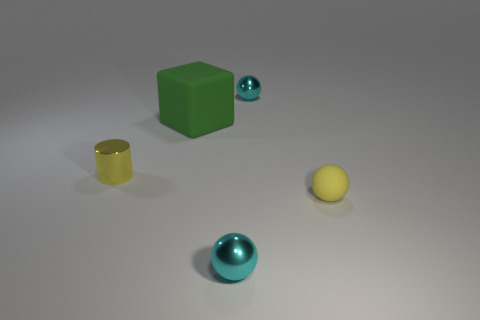Subtract all tiny yellow spheres. How many spheres are left? 2 Add 1 small cyan metallic things. How many objects exist? 6 Subtract all gray cylinders. How many cyan balls are left? 2 Subtract 2 balls. How many balls are left? 1 Subtract all blocks. How many objects are left? 4 Subtract 2 cyan balls. How many objects are left? 3 Subtract all blue spheres. Subtract all brown cylinders. How many spheres are left? 3 Subtract all small yellow rubber objects. Subtract all big blocks. How many objects are left? 3 Add 1 small metallic things. How many small metallic things are left? 4 Add 2 yellow metal objects. How many yellow metal objects exist? 3 